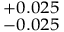<formula> <loc_0><loc_0><loc_500><loc_500>^ { + 0 . 0 2 5 } _ { - 0 . 0 2 5 }</formula> 